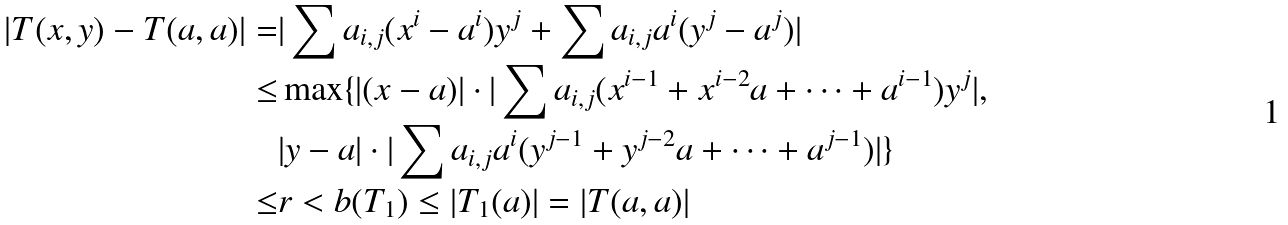Convert formula to latex. <formula><loc_0><loc_0><loc_500><loc_500>| T ( x , y ) - T ( a , a ) | = & | \sum a _ { i , j } ( x ^ { i } - a ^ { i } ) y ^ { j } + \sum a _ { i , j } a ^ { i } ( y ^ { j } - a ^ { j } ) | \\ \leq & \max \{ | ( x - a ) | \cdot | \sum a _ { i , j } ( x ^ { i - 1 } + x ^ { i - 2 } a + \cdots + a ^ { i - 1 } ) y ^ { j } | , \\ & | y - a | \cdot | \sum a _ { i , j } a ^ { i } ( y ^ { j - 1 } + y ^ { j - 2 } a + \cdots + a ^ { j - 1 } ) | \} \\ \leq & r < b ( T _ { 1 } ) \leq | T _ { 1 } ( a ) | = | T ( a , a ) |</formula> 